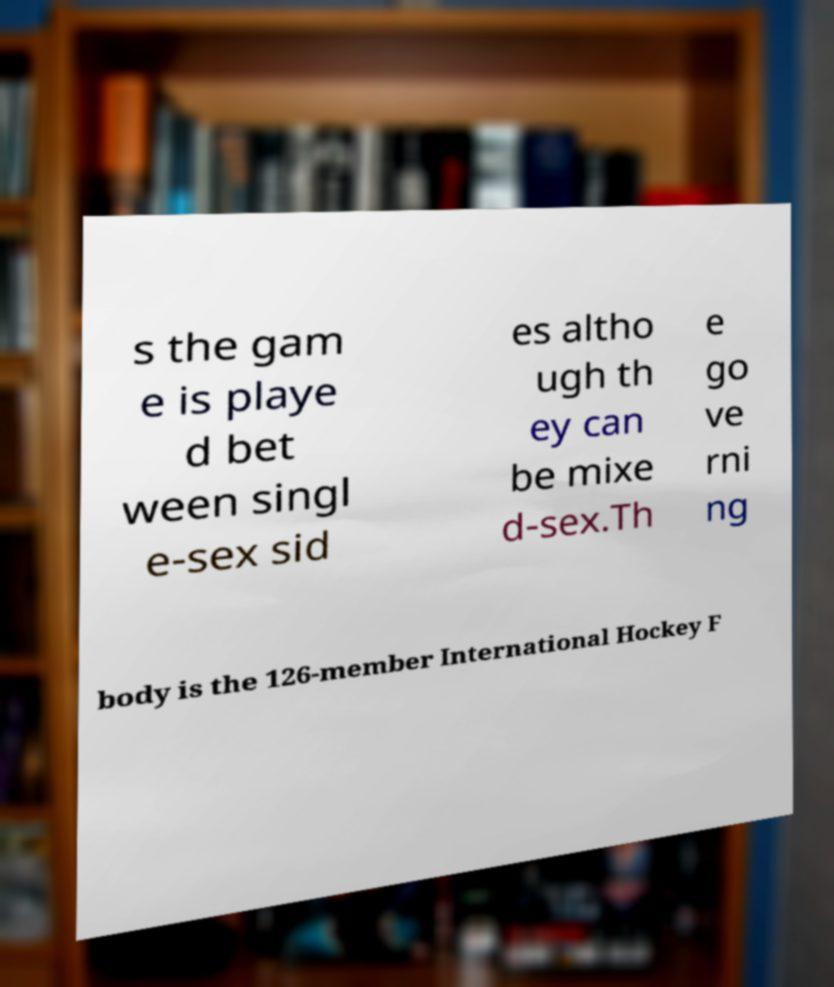Could you extract and type out the text from this image? s the gam e is playe d bet ween singl e-sex sid es altho ugh th ey can be mixe d-sex.Th e go ve rni ng body is the 126-member International Hockey F 